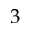<formula> <loc_0><loc_0><loc_500><loc_500>3</formula> 